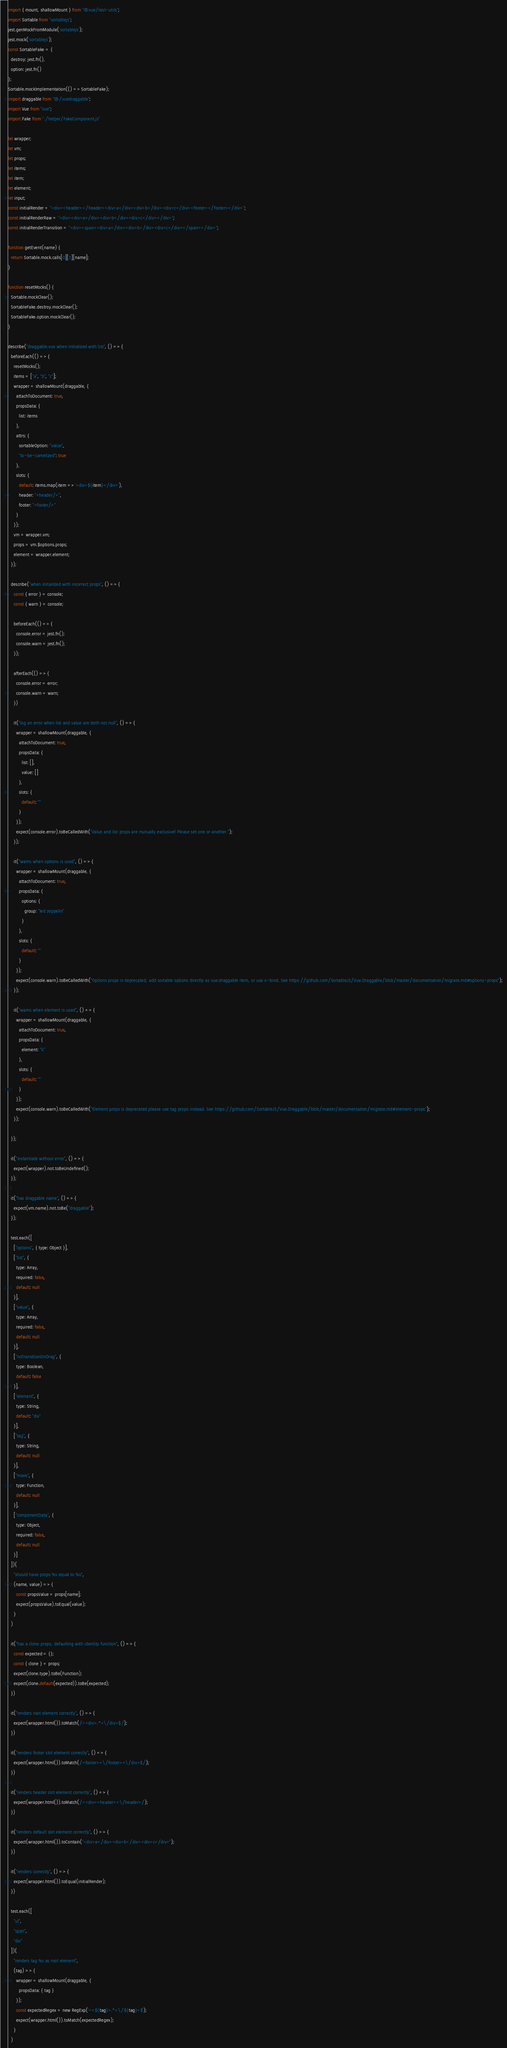<code> <loc_0><loc_0><loc_500><loc_500><_JavaScript_>import { mount, shallowMount } from "@vue/test-utils";
import Sortable from "sortablejs";
jest.genMockFromModule('sortablejs');
jest.mock('sortablejs');
const SortableFake = {
  destroy: jest.fn(),
  option: jest.fn()
};
Sortable.mockImplementation(() => SortableFake);
import draggable from "@/vuedraggable";
import Vue from "vue";
import Fake from "./helper/FakeComponent.js"

let wrapper;
let vm;
let props;
let items;
let item;
let element;
let input;
const initialRender = "<div><header></header><div>a</div><div>b</div><div>c</div><footer></footer></div>";
const initialRenderRaw = "<div><div>a</div><div>b</div><div>c</div></div>";
const initialRenderTransition = "<div><span><div>a</div><div>b</div><div>c</div></span></div>";

function getEvent(name) {
  return Sortable.mock.calls[0][1][name];
}

function resetMocks() {
  Sortable.mockClear();
  SortableFake.destroy.mockClear();
  SortableFake.option.mockClear();
}

describe("draggable.vue when initialized with list", () => {
  beforeEach(() => {
    resetMocks();
    items = ["a", "b", "c"];
    wrapper = shallowMount(draggable, {
      attachToDocument: true,
      propsData: {
        list: items
      },
      attrs: {
        sortableOption: "value",
        "to-be-camelized": true
      },
      slots: {
        default: items.map(item => `<div>${item}</div>`),
        header: "<header/>",
        footer: "<footer/>"
      }
    });
    vm = wrapper.vm;
    props = vm.$options.props;
    element = wrapper.element;
  });

  describe("when initialized with incorrect props", () => {
    const { error } = console;
    const { warn } = console;

    beforeEach(() => {
      console.error = jest.fn();
      console.warn = jest.fn();
    });

    afterEach(() => {
      console.error = error;
      console.warn = warn;
    })

    it("log an error when list and value are both not null", () => {
      wrapper = shallowMount(draggable, {
        attachToDocument: true,
        propsData: {
          list: [],
          value: []
        },
        slots: {
          default: ""
        }
      });
      expect(console.error).toBeCalledWith("Value and list props are mutually exclusive! Please set one or another.");
    });

    it("warns when options is used", () => {
      wrapper = shallowMount(draggable, {
        attachToDocument: true,
        propsData: {
          options: {
            group: "led zeppelin"
          }
        },
        slots: {
          default: ""
        }
      });
      expect(console.warn).toBeCalledWith("Options props is deprecated, add sortable options directly as vue.draggable item, or use v-bind. See https://github.com/SortableJS/Vue.Draggable/blob/master/documentation/migrate.md#options-props");
    });

    it("warns when element is used", () => {
      wrapper = shallowMount(draggable, {
        attachToDocument: true,
        propsData: {
          element: "li"
        },
        slots: {
          default: ""
        }
      });
      expect(console.warn).toBeCalledWith("Element props is deprecated please use tag props instead. See https://github.com/SortableJS/Vue.Draggable/blob/master/documentation/migrate.md#element-props");
    });

  });

  it("instantiate without error", () => {
    expect(wrapper).not.toBeUndefined();
  });

  it("has draggable name", () => {
    expect(vm.name).not.toBe("draggable");
  });

  test.each([
    ["options", { type: Object }],
    ["list", {
      type: Array,
      required: false,
      default: null
    }],
    ["value", {
      type: Array,
      required: false,
      default: null
    }],
    ["noTransitionOnDrag", {
      type: Boolean,
      default: false
    }],
    ["element", {
      type: String,
      default: "div"
    }],
    ["tag", {
      type: String,
      default: null
    }],
    ["move", {
      type: Function,
      default: null
    }],
    ["componentData", {
      type: Object,
      required: false,
      default: null
    }]
  ])(
    "should have props %s equal to %o",
    (name, value) => {
      const propsValue = props[name];
      expect(propsValue).toEqual(value);
    }
  )

  it("has a clone props, defaulting with identity function", () => {
    const expected = {};
    const { clone } = props;
    expect(clone.type).toBe(Function);
    expect(clone.default(expected)).toBe(expected);
  })

  it("renders root element correctly", () => {
    expect(wrapper.html()).toMatch(/^<div>.*<\/div>$/);
  })

  it("renders footer slot element correctly", () => {
    expect(wrapper.html()).toMatch(/<footer><\/footer><\/div>$/);
  })

  it("renders header slot element correctly", () => {
    expect(wrapper.html()).toMatch(/^<div><header><\/header>/);
  })

  it("renders default slot element correctly", () => {
    expect(wrapper.html()).toContain("<div>a</div><div>b</div><div>c</div>");
  })

  it("renders correctly", () => {
    expect(wrapper.html()).toEqual(initialRender);
  })

  test.each([
    "ul",
    "span",
    "div"
  ])(
    "renders tag %s as root element",
    (tag) => {
      wrapper = shallowMount(draggable, {
        propsData: { tag }
      });
      const expectedRegex = new RegExp(`^<${tag}>.*<\/${tag}>$`);
      expect(wrapper.html()).toMatch(expectedRegex);
    }
  )
</code> 